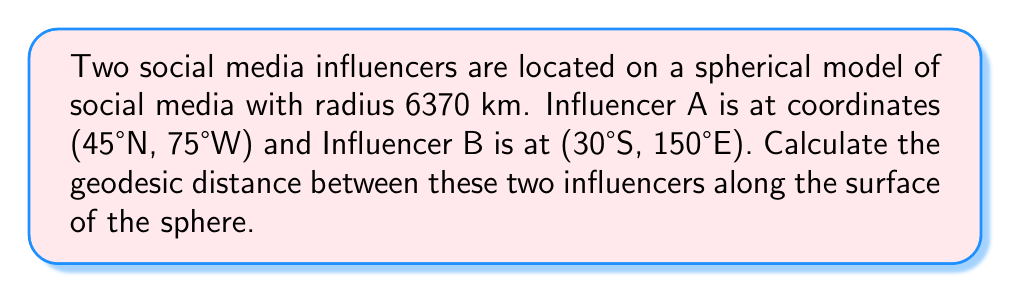Solve this math problem. To solve this problem, we'll use the spherical law of cosines formula for geodesic distance on a sphere. Let's break it down step-by-step:

1. Convert the given coordinates to radians:
   $\phi_1 = 45°N = \frac{\pi}{4}$ rad
   $\lambda_1 = 75°W = -\frac{5\pi}{12}$ rad
   $\phi_2 = 30°S = -\frac{\pi}{6}$ rad
   $\lambda_2 = 150°E = \frac{5\pi}{6}$ rad

2. Use the spherical law of cosines formula:
   $$\cos(c) = \sin(\phi_1)\sin(\phi_2) + \cos(\phi_1)\cos(\phi_2)\cos(\lambda_2 - \lambda_1)$$
   
   Where $c$ is the central angle between the two points.

3. Substitute the values:
   $$\cos(c) = \sin(\frac{\pi}{4})\sin(-\frac{\pi}{6}) + \cos(\frac{\pi}{4})\cos(-\frac{\pi}{6})\cos(\frac{5\pi}{6} - (-\frac{5\pi}{12}))$$

4. Simplify:
   $$\cos(c) = \frac{\sqrt{2}}{2} \cdot (-\frac{1}{2}) + \frac{\sqrt{2}}{2} \cdot \frac{\sqrt{3}}{2} \cdot \cos(\frac{15\pi}{12})$$

5. Calculate the result:
   $$\cos(c) \approx -0.2580$$

6. Take the inverse cosine to find the central angle:
   $$c = \arccos(-0.2580) \approx 1.8349 \text{ radians}$$

7. Calculate the geodesic distance using the radius of the sphere:
   $$d = R \cdot c = 6370 \text{ km} \cdot 1.8349 \approx 11688.3 \text{ km}$$

[asy]
import geometry;

size(200);
pair O=(0,0);
real R=5;
draw(circle(O,R));
pair A=R*dir(45);
pair B=R*dir(-150);
draw(O--A,dashed);
draw(O--B,dashed);
draw(A--B,red);
label("A",A,NE);
label("B",B,SE);
label("O",O,W);
[/asy]
Answer: 11688.3 km 